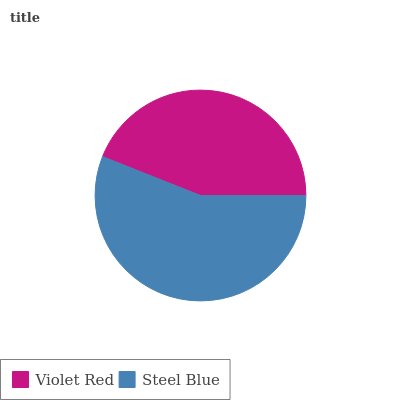Is Violet Red the minimum?
Answer yes or no. Yes. Is Steel Blue the maximum?
Answer yes or no. Yes. Is Steel Blue the minimum?
Answer yes or no. No. Is Steel Blue greater than Violet Red?
Answer yes or no. Yes. Is Violet Red less than Steel Blue?
Answer yes or no. Yes. Is Violet Red greater than Steel Blue?
Answer yes or no. No. Is Steel Blue less than Violet Red?
Answer yes or no. No. Is Steel Blue the high median?
Answer yes or no. Yes. Is Violet Red the low median?
Answer yes or no. Yes. Is Violet Red the high median?
Answer yes or no. No. Is Steel Blue the low median?
Answer yes or no. No. 